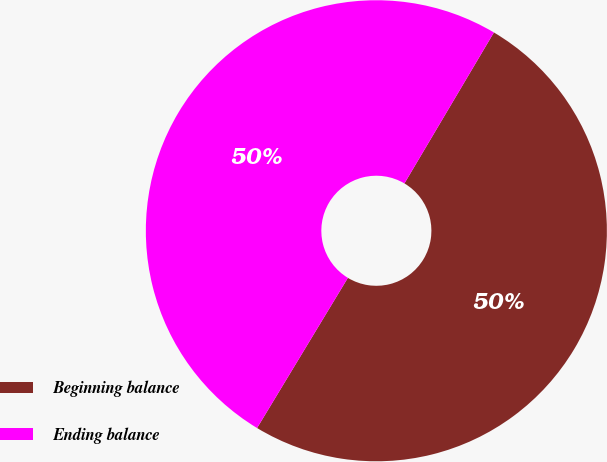Convert chart. <chart><loc_0><loc_0><loc_500><loc_500><pie_chart><fcel>Beginning balance<fcel>Ending balance<nl><fcel>50.14%<fcel>49.86%<nl></chart> 